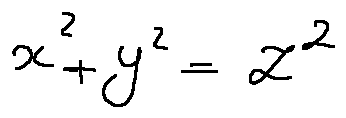<formula> <loc_0><loc_0><loc_500><loc_500>x ^ { 2 } + y ^ { 2 } = z ^ { 2 }</formula> 